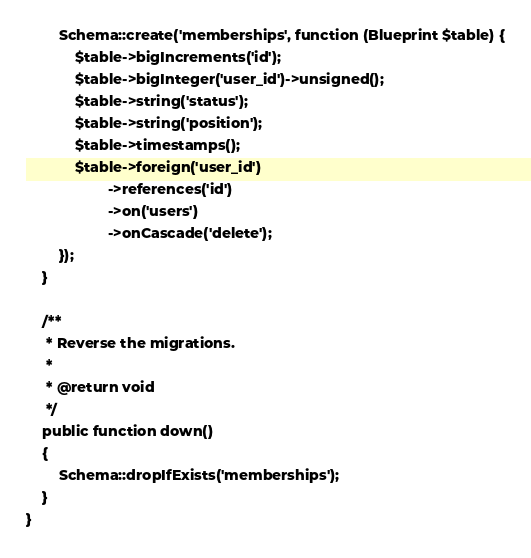Convert code to text. <code><loc_0><loc_0><loc_500><loc_500><_PHP_>        Schema::create('memberships', function (Blueprint $table) {
            $table->bigIncrements('id');
            $table->bigInteger('user_id')->unsigned();
            $table->string('status');
            $table->string('position');
            $table->timestamps();
            $table->foreign('user_id')
                    ->references('id')
                    ->on('users')
                    ->onCascade('delete');
        });
    }

    /**
     * Reverse the migrations.
     *
     * @return void
     */
    public function down()
    {
        Schema::dropIfExists('memberships');
    }
}
</code> 